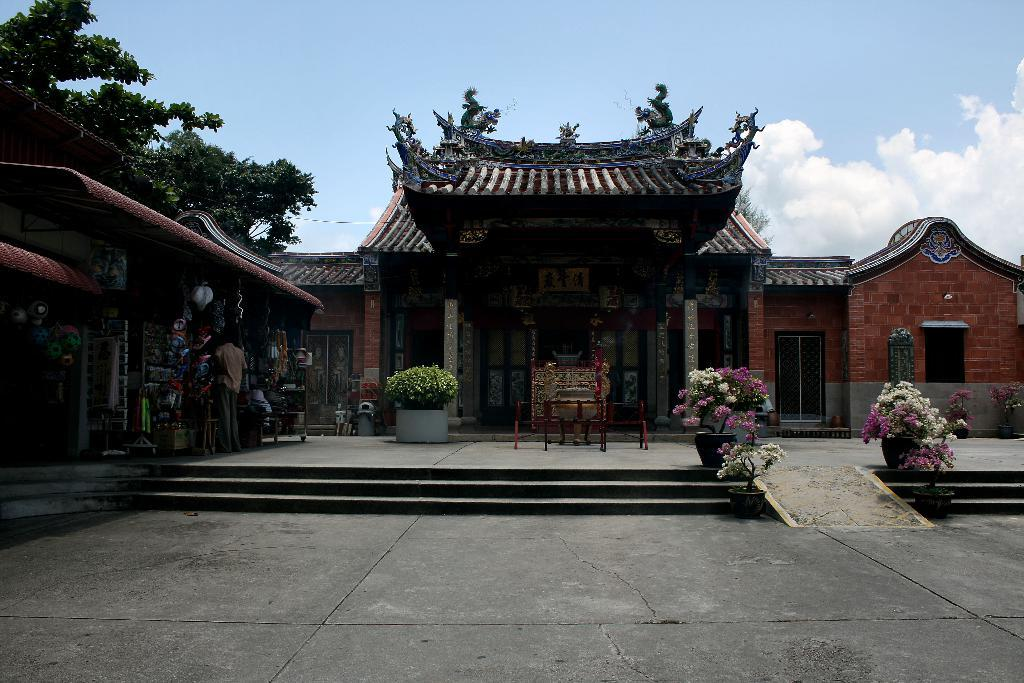What type of structure is present in the image? There is a building in the image. What can be seen near the building? There are flower pots and trees in the image. What type of establishment is located in the building? There is a shop in the image. Is there anyone present in the image? Yes, there is a person standing on the ground in the image. What else can be seen in the image besides the building, trees, and person? There are other objects in the image. What is visible in the background of the image? The sky is visible in the background of the image. What type of hair can be seen on the trees in the image? Trees do not have hair; they have leaves and branches. 